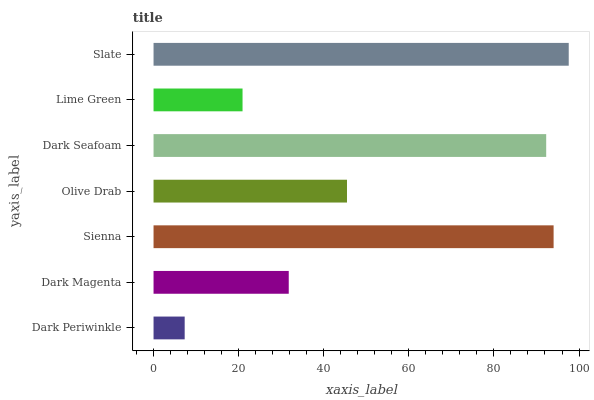Is Dark Periwinkle the minimum?
Answer yes or no. Yes. Is Slate the maximum?
Answer yes or no. Yes. Is Dark Magenta the minimum?
Answer yes or no. No. Is Dark Magenta the maximum?
Answer yes or no. No. Is Dark Magenta greater than Dark Periwinkle?
Answer yes or no. Yes. Is Dark Periwinkle less than Dark Magenta?
Answer yes or no. Yes. Is Dark Periwinkle greater than Dark Magenta?
Answer yes or no. No. Is Dark Magenta less than Dark Periwinkle?
Answer yes or no. No. Is Olive Drab the high median?
Answer yes or no. Yes. Is Olive Drab the low median?
Answer yes or no. Yes. Is Slate the high median?
Answer yes or no. No. Is Lime Green the low median?
Answer yes or no. No. 